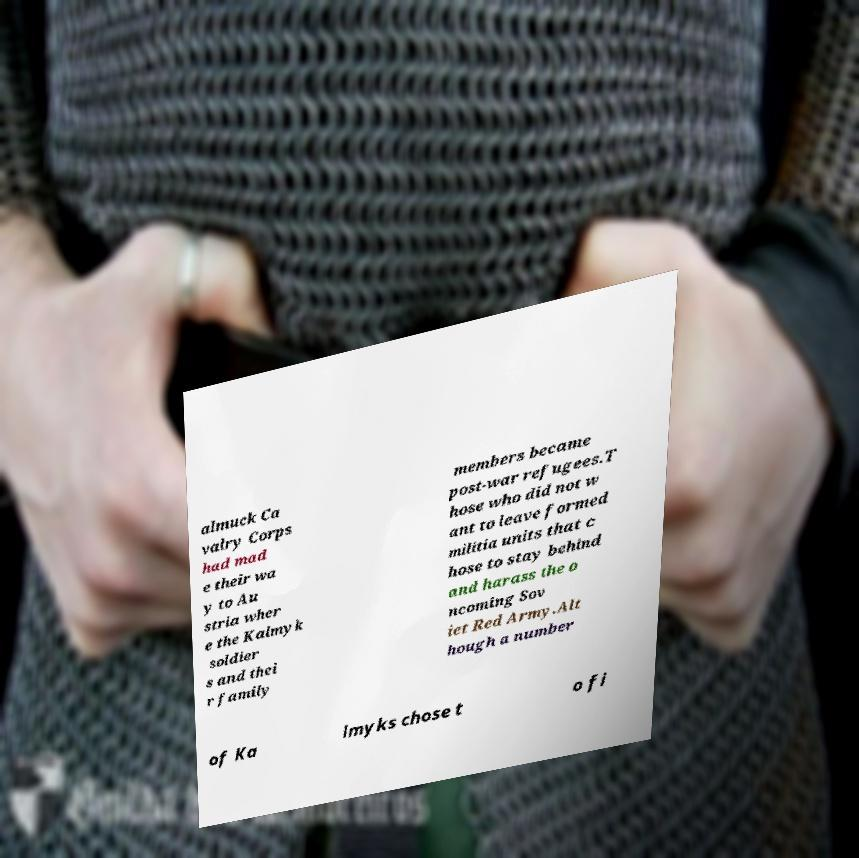Could you assist in decoding the text presented in this image and type it out clearly? almuck Ca valry Corps had mad e their wa y to Au stria wher e the Kalmyk soldier s and thei r family members became post-war refugees.T hose who did not w ant to leave formed militia units that c hose to stay behind and harass the o ncoming Sov iet Red Army.Alt hough a number of Ka lmyks chose t o fi 